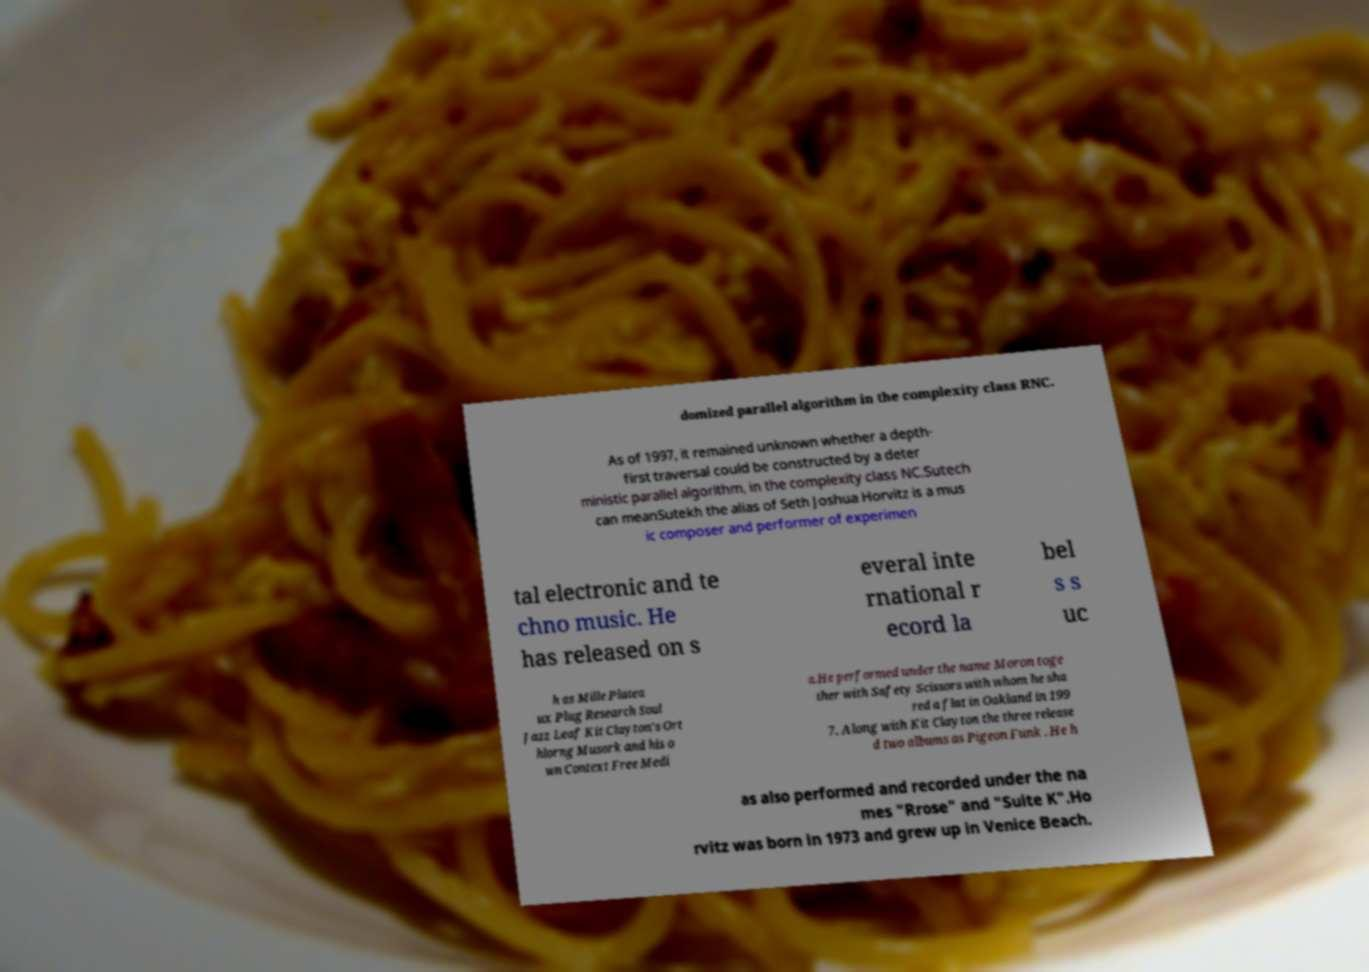I need the written content from this picture converted into text. Can you do that? domized parallel algorithm in the complexity class RNC. As of 1997, it remained unknown whether a depth- first traversal could be constructed by a deter ministic parallel algorithm, in the complexity class NC.Sutech can meanSutekh the alias of Seth Joshua Horvitz is a mus ic composer and performer of experimen tal electronic and te chno music. He has released on s everal inte rnational r ecord la bel s s uc h as Mille Platea ux Plug Research Soul Jazz Leaf Kit Clayton's Ort hlorng Musork and his o wn Context Free Medi a.He performed under the name Moron toge ther with Safety Scissors with whom he sha red a flat in Oakland in 199 7. Along with Kit Clayton the three release d two albums as Pigeon Funk . He h as also performed and recorded under the na mes "Rrose" and "Suite K".Ho rvitz was born in 1973 and grew up in Venice Beach. 